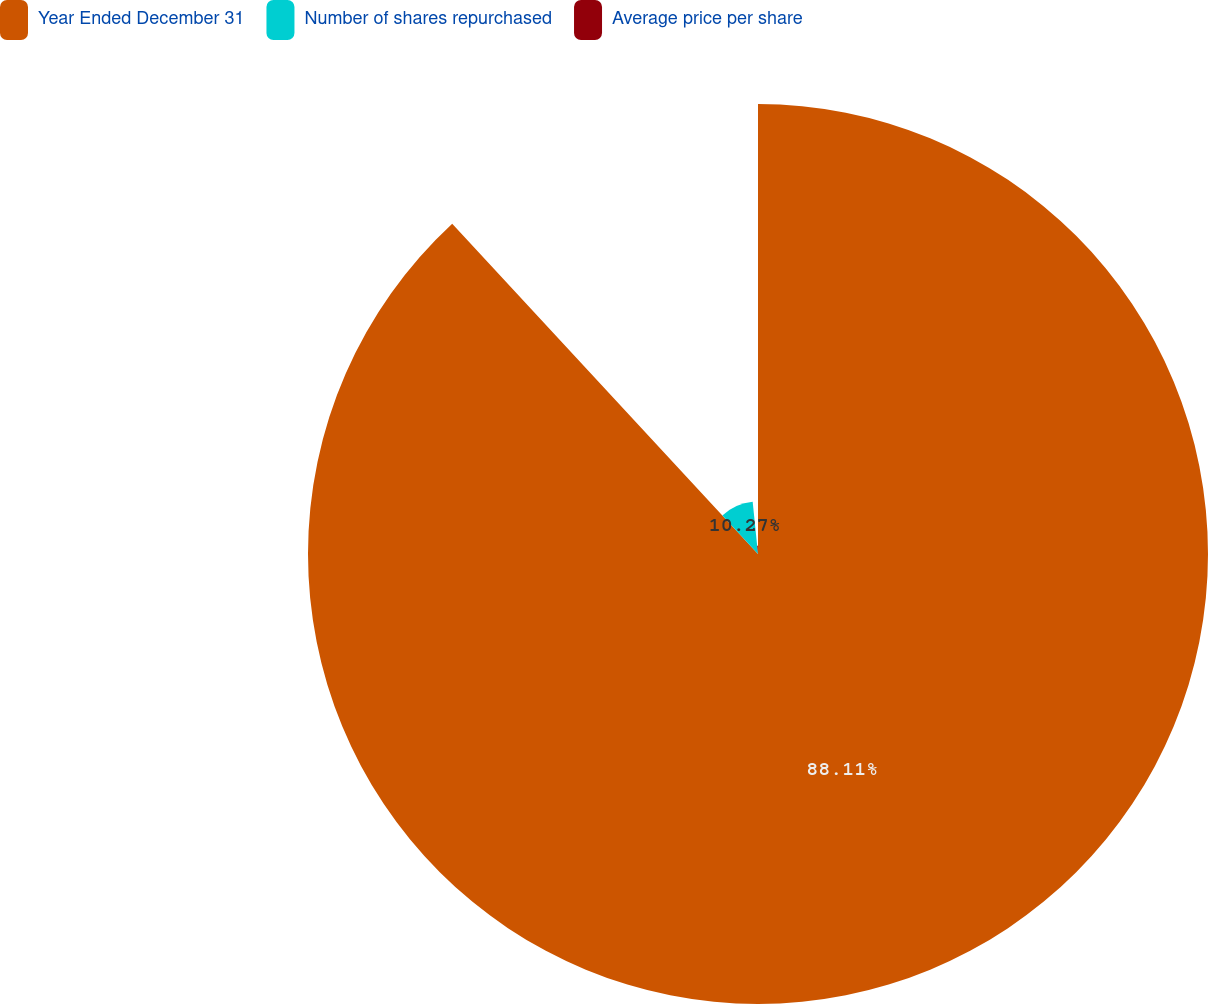Convert chart. <chart><loc_0><loc_0><loc_500><loc_500><pie_chart><fcel>Year Ended December 31<fcel>Number of shares repurchased<fcel>Average price per share<nl><fcel>88.1%<fcel>10.27%<fcel>1.62%<nl></chart> 